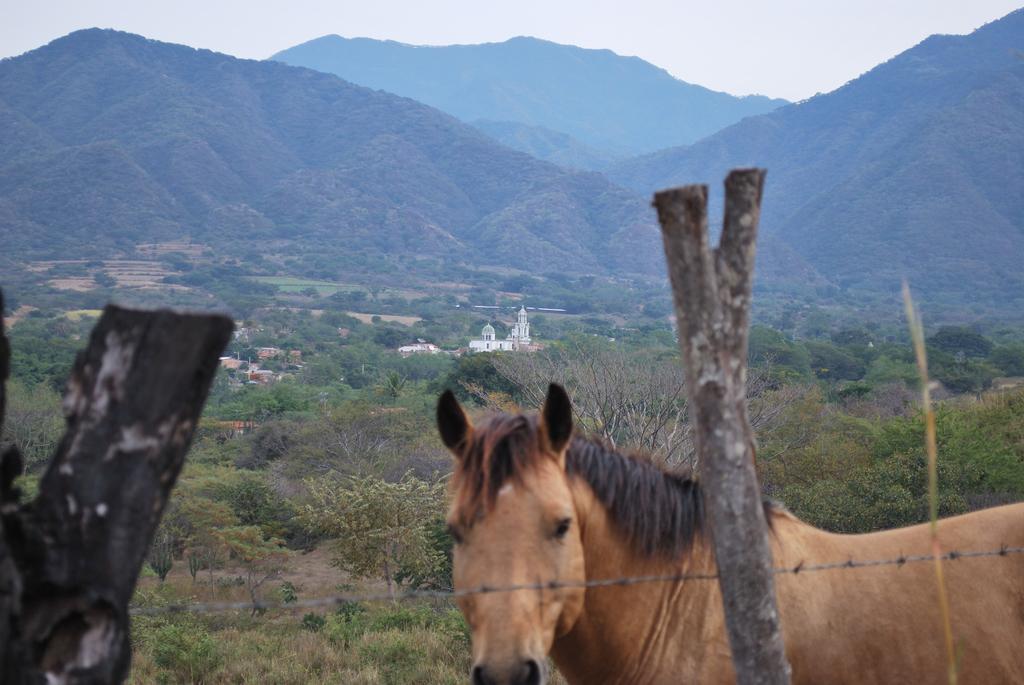Could you give a brief overview of what you see in this image? In this picture we can see wooden poles and a wire fence from left to right. We can see a horse on the right side. There are a few plants, trees, buildings and mountains are visible in the background. We can see the sky on top of the picture. 